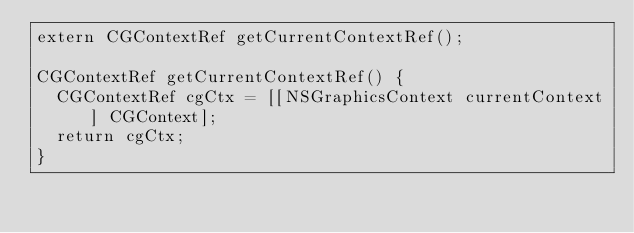<code> <loc_0><loc_0><loc_500><loc_500><_ObjectiveC_>extern CGContextRef getCurrentContextRef();

CGContextRef getCurrentContextRef() {
  CGContextRef cgCtx = [[NSGraphicsContext currentContext] CGContext];
  return cgCtx;
}
</code> 